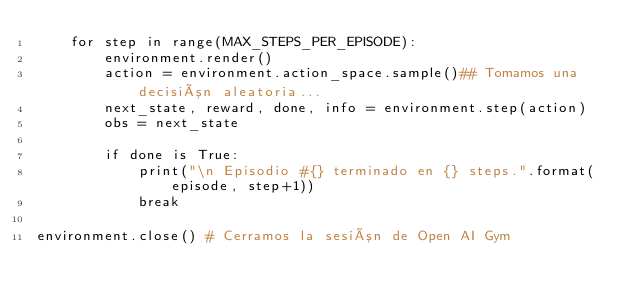<code> <loc_0><loc_0><loc_500><loc_500><_Python_>    for step in range(MAX_STEPS_PER_EPISODE):
        environment.render()
        action = environment.action_space.sample()## Tomamos una decisión aleatoria...
        next_state, reward, done, info = environment.step(action)
        obs = next_state
        
        if done is True:
            print("\n Episodio #{} terminado en {} steps.".format(episode, step+1))
            break
        
environment.close() # Cerramos la sesión de Open AI Gym</code> 